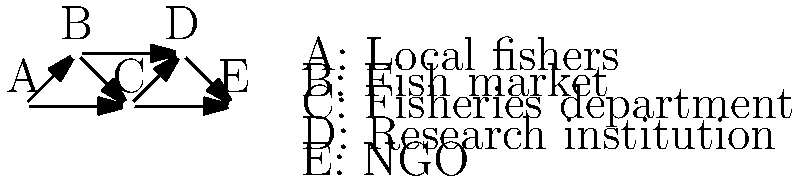In the social network diagram of a fishing community, which node has the highest betweenness centrality, potentially playing a crucial role in information flow and resource management decisions? To determine the node with the highest betweenness centrality, we need to follow these steps:

1. Understand betweenness centrality: It measures how often a node appears on the shortest paths between other nodes in the network.

2. Identify all shortest paths:
   - A to D: A-B-D or A-C-D
   - A to E: A-C-E
   - B to E: B-C-E or B-D-E
   - D to A: D-B-A or D-C-A

3. Count how many times each node appears on these shortest paths:
   A: 0
   B: 2
   C: 5
   D: 2
   E: 0

4. Node C (Fisheries department) appears most frequently on the shortest paths between other nodes.

5. This high betweenness centrality suggests that the Fisheries department plays a crucial role in:
   - Facilitating information flow between different stakeholders
   - Potentially influencing resource management decisions
   - Acting as a bridge between local fishers, markets, research institutions, and NGOs

Therefore, node C (Fisheries department) has the highest betweenness centrality in this social network.
Answer: C (Fisheries department) 